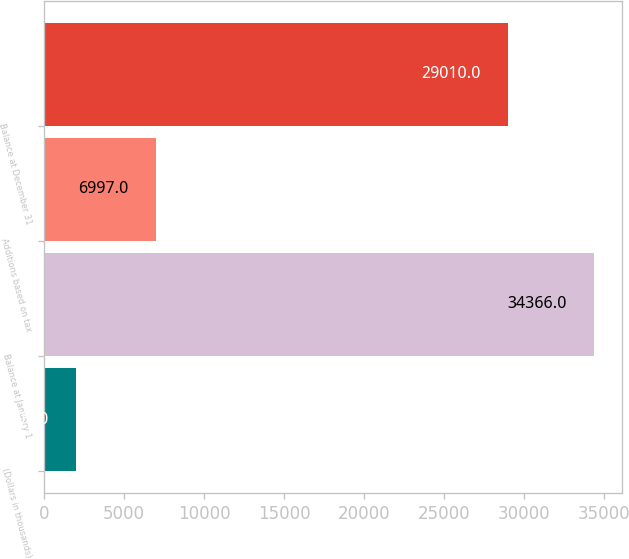Convert chart. <chart><loc_0><loc_0><loc_500><loc_500><bar_chart><fcel>(Dollars in thousands)<fcel>Balance at January 1<fcel>Additions based on tax<fcel>Balance at December 31<nl><fcel>2009<fcel>34366<fcel>6997<fcel>29010<nl></chart> 